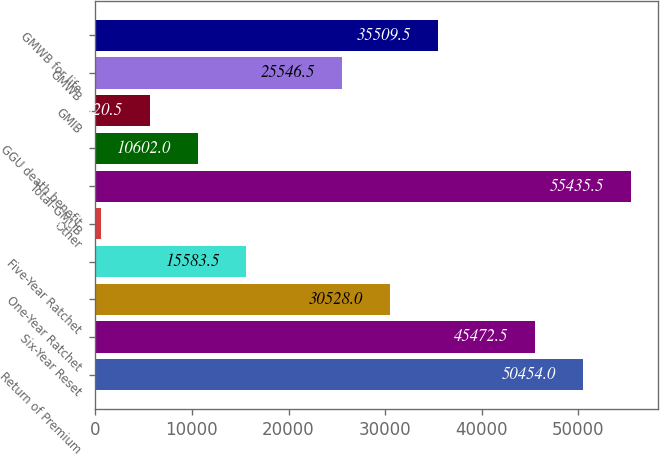<chart> <loc_0><loc_0><loc_500><loc_500><bar_chart><fcel>Return of Premium<fcel>Six-Year Reset<fcel>One-Year Ratchet<fcel>Five-Year Ratchet<fcel>Other<fcel>Total-GMDB<fcel>GGU death benefit<fcel>GMIB<fcel>GMWB<fcel>GMWB for life<nl><fcel>50454<fcel>45472.5<fcel>30528<fcel>15583.5<fcel>639<fcel>55435.5<fcel>10602<fcel>5620.5<fcel>25546.5<fcel>35509.5<nl></chart> 